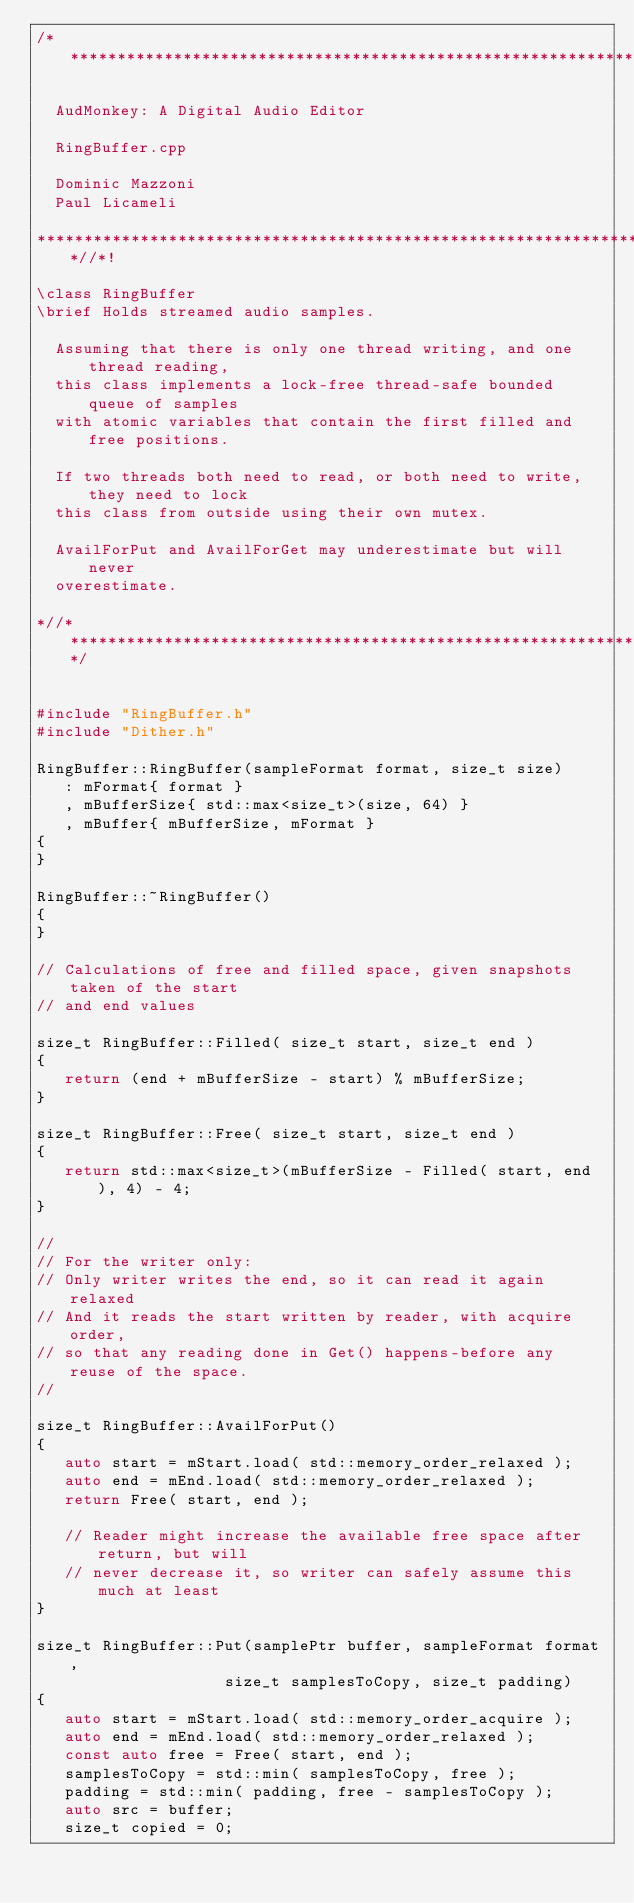<code> <loc_0><loc_0><loc_500><loc_500><_C++_>/**********************************************************************

  AudMonkey: A Digital Audio Editor

  RingBuffer.cpp

  Dominic Mazzoni
  Paul Licameli

*******************************************************************//*!

\class RingBuffer
\brief Holds streamed audio samples.

  Assuming that there is only one thread writing, and one thread reading,
  this class implements a lock-free thread-safe bounded queue of samples
  with atomic variables that contain the first filled and free positions.
                                                                     
  If two threads both need to read, or both need to write, they need to lock
  this class from outside using their own mutex.

  AvailForPut and AvailForGet may underestimate but will never
  overestimate.

*//*******************************************************************/


#include "RingBuffer.h"
#include "Dither.h"

RingBuffer::RingBuffer(sampleFormat format, size_t size)
   : mFormat{ format }
   , mBufferSize{ std::max<size_t>(size, 64) }
   , mBuffer{ mBufferSize, mFormat }
{
}

RingBuffer::~RingBuffer()
{
}

// Calculations of free and filled space, given snapshots taken of the start
// and end values

size_t RingBuffer::Filled( size_t start, size_t end )
{
   return (end + mBufferSize - start) % mBufferSize;
}

size_t RingBuffer::Free( size_t start, size_t end )
{
   return std::max<size_t>(mBufferSize - Filled( start, end ), 4) - 4;
}

//
// For the writer only:
// Only writer writes the end, so it can read it again relaxed
// And it reads the start written by reader, with acquire order,
// so that any reading done in Get() happens-before any reuse of the space.
//

size_t RingBuffer::AvailForPut()
{
   auto start = mStart.load( std::memory_order_relaxed );
   auto end = mEnd.load( std::memory_order_relaxed );
   return Free( start, end );

   // Reader might increase the available free space after return, but will
   // never decrease it, so writer can safely assume this much at least
}

size_t RingBuffer::Put(samplePtr buffer, sampleFormat format,
                    size_t samplesToCopy, size_t padding)
{
   auto start = mStart.load( std::memory_order_acquire );
   auto end = mEnd.load( std::memory_order_relaxed );
   const auto free = Free( start, end );
   samplesToCopy = std::min( samplesToCopy, free );
   padding = std::min( padding, free - samplesToCopy );
   auto src = buffer;
   size_t copied = 0;</code> 